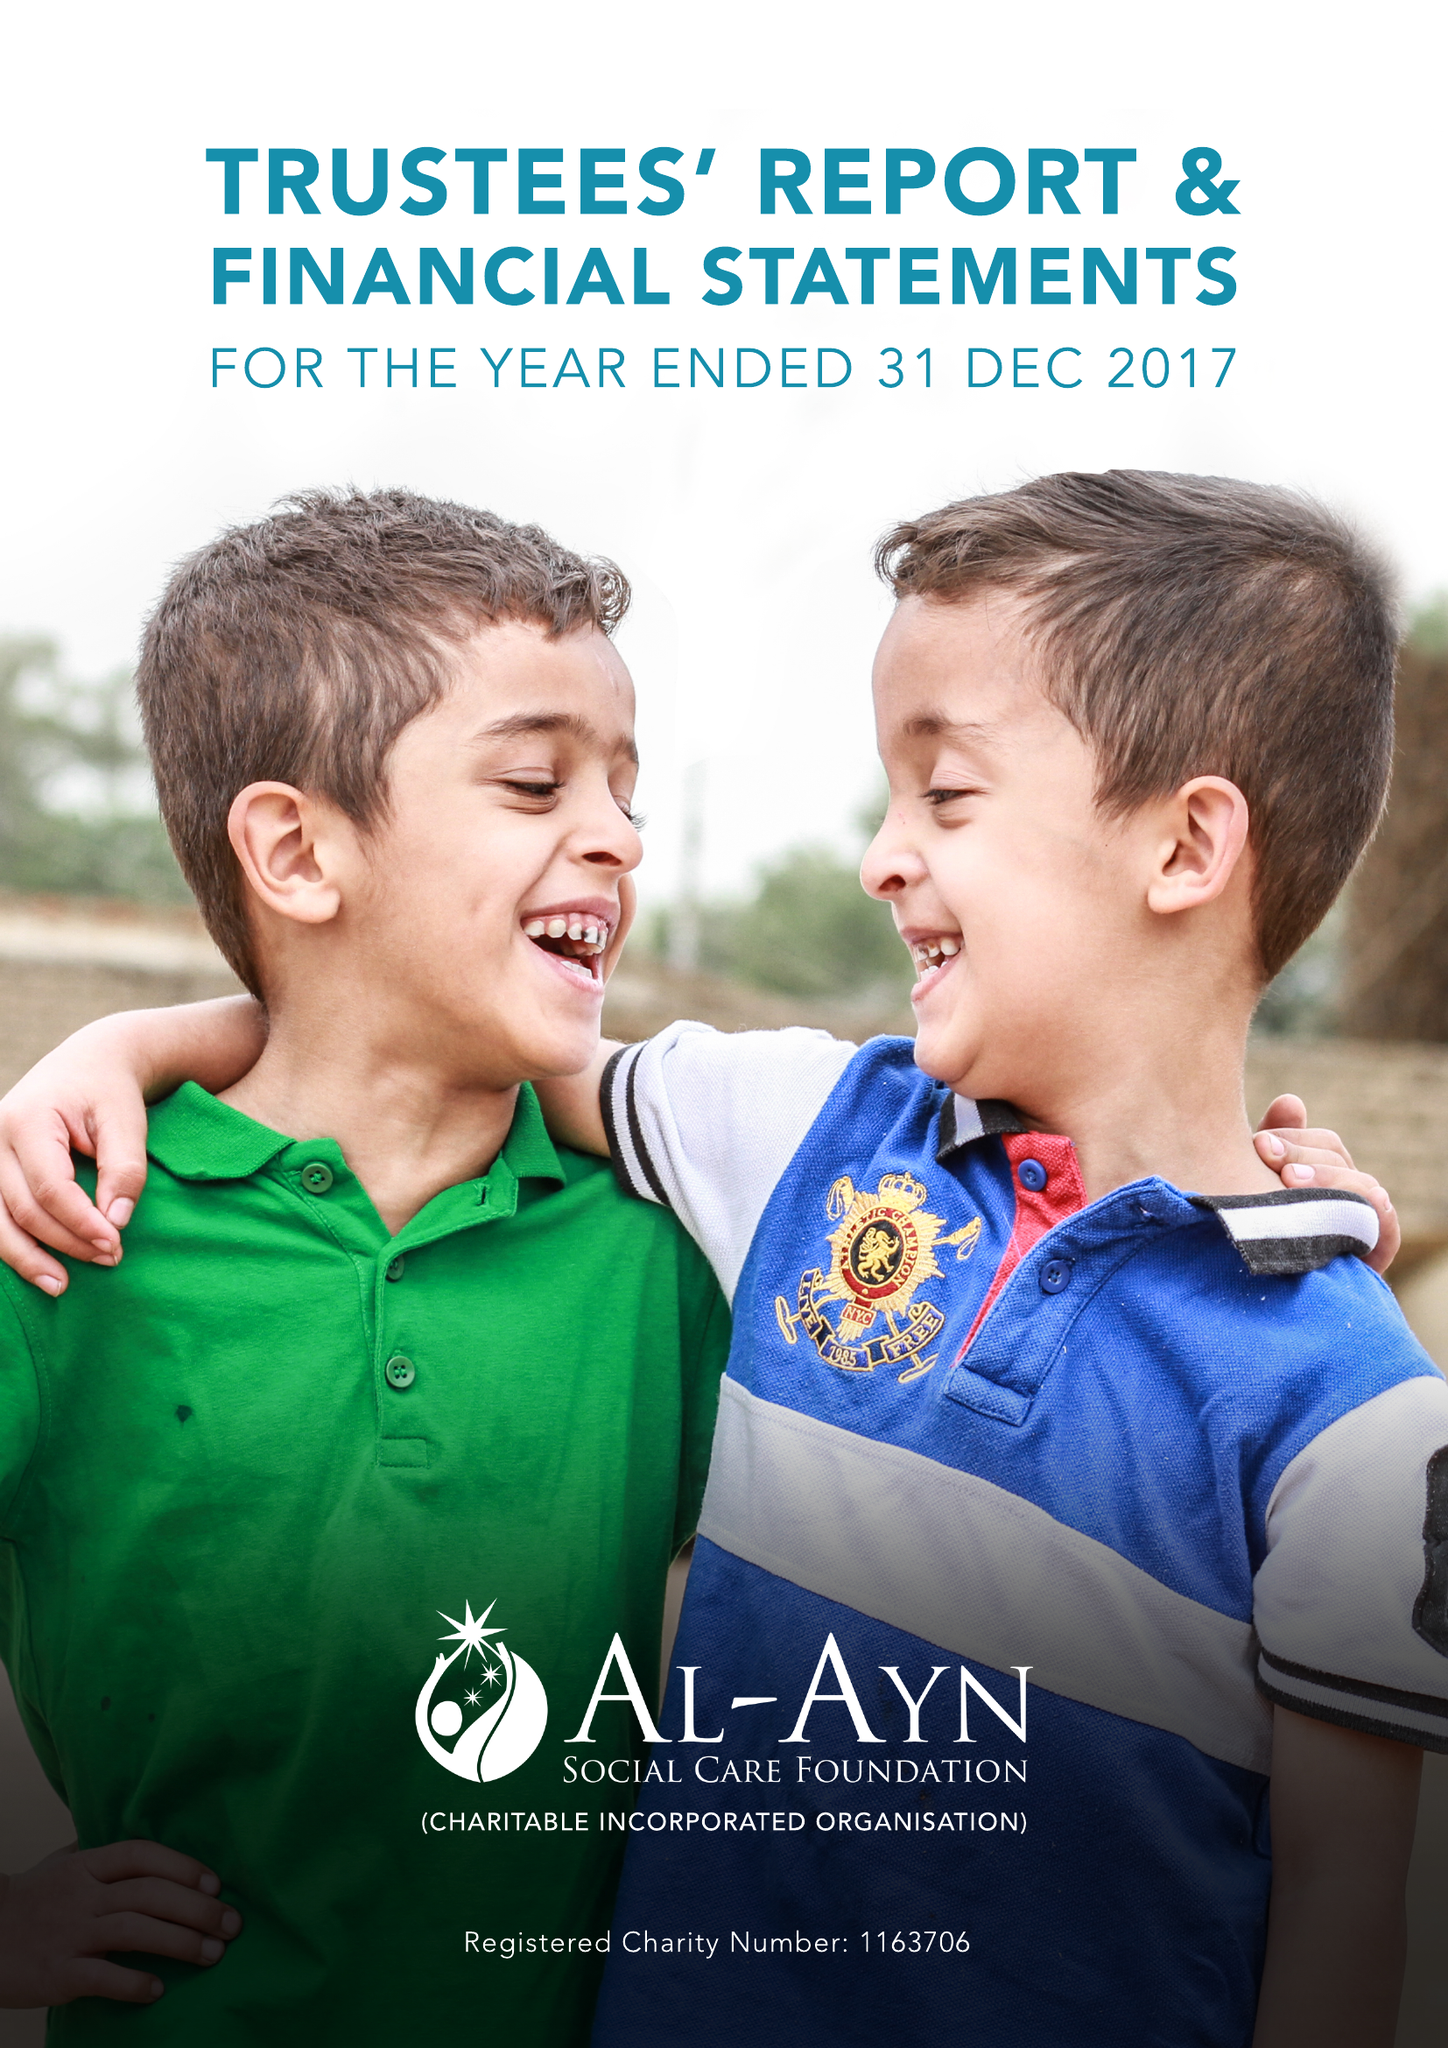What is the value for the report_date?
Answer the question using a single word or phrase. 2017-12-31 